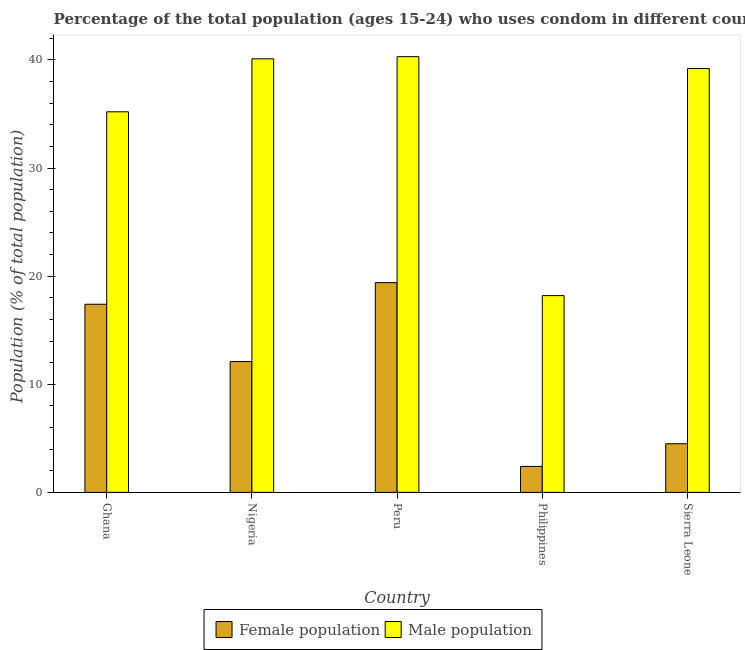How many different coloured bars are there?
Offer a terse response. 2. How many groups of bars are there?
Provide a short and direct response. 5. Are the number of bars on each tick of the X-axis equal?
Provide a short and direct response. Yes. How many bars are there on the 4th tick from the right?
Give a very brief answer. 2. What is the label of the 5th group of bars from the left?
Your answer should be very brief. Sierra Leone. In how many cases, is the number of bars for a given country not equal to the number of legend labels?
Offer a terse response. 0. What is the male population in Peru?
Give a very brief answer. 40.3. Across all countries, what is the maximum female population?
Offer a very short reply. 19.4. Across all countries, what is the minimum female population?
Ensure brevity in your answer.  2.4. In which country was the female population maximum?
Give a very brief answer. Peru. In which country was the female population minimum?
Ensure brevity in your answer.  Philippines. What is the total male population in the graph?
Keep it short and to the point. 173. What is the difference between the female population in Peru and that in Sierra Leone?
Make the answer very short. 14.9. What is the difference between the female population in Peru and the male population in Nigeria?
Make the answer very short. -20.7. What is the average male population per country?
Provide a succinct answer. 34.6. What is the difference between the male population and female population in Nigeria?
Your answer should be compact. 28. In how many countries, is the female population greater than 20 %?
Keep it short and to the point. 0. What is the ratio of the female population in Ghana to that in Peru?
Offer a terse response. 0.9. What is the difference between the highest and the second highest female population?
Provide a short and direct response. 2. Is the sum of the female population in Ghana and Peru greater than the maximum male population across all countries?
Make the answer very short. No. What does the 1st bar from the left in Peru represents?
Ensure brevity in your answer.  Female population. What does the 1st bar from the right in Ghana represents?
Make the answer very short. Male population. Are the values on the major ticks of Y-axis written in scientific E-notation?
Your answer should be compact. No. Where does the legend appear in the graph?
Offer a very short reply. Bottom center. What is the title of the graph?
Ensure brevity in your answer.  Percentage of the total population (ages 15-24) who uses condom in different countries. Does "Taxes on profits and capital gains" appear as one of the legend labels in the graph?
Your answer should be compact. No. What is the label or title of the X-axis?
Offer a very short reply. Country. What is the label or title of the Y-axis?
Your answer should be compact. Population (% of total population) . What is the Population (% of total population)  in Female population in Ghana?
Keep it short and to the point. 17.4. What is the Population (% of total population)  in Male population in Ghana?
Give a very brief answer. 35.2. What is the Population (% of total population)  in Female population in Nigeria?
Your response must be concise. 12.1. What is the Population (% of total population)  in Male population in Nigeria?
Ensure brevity in your answer.  40.1. What is the Population (% of total population)  of Male population in Peru?
Ensure brevity in your answer.  40.3. What is the Population (% of total population)  in Female population in Philippines?
Make the answer very short. 2.4. What is the Population (% of total population)  in Male population in Sierra Leone?
Provide a short and direct response. 39.2. Across all countries, what is the maximum Population (% of total population)  in Male population?
Offer a terse response. 40.3. What is the total Population (% of total population)  of Female population in the graph?
Your answer should be compact. 55.8. What is the total Population (% of total population)  of Male population in the graph?
Your answer should be very brief. 173. What is the difference between the Population (% of total population)  in Female population in Ghana and that in Nigeria?
Ensure brevity in your answer.  5.3. What is the difference between the Population (% of total population)  of Female population in Ghana and that in Peru?
Provide a succinct answer. -2. What is the difference between the Population (% of total population)  of Female population in Ghana and that in Philippines?
Keep it short and to the point. 15. What is the difference between the Population (% of total population)  of Male population in Ghana and that in Philippines?
Keep it short and to the point. 17. What is the difference between the Population (% of total population)  of Female population in Ghana and that in Sierra Leone?
Provide a succinct answer. 12.9. What is the difference between the Population (% of total population)  of Male population in Ghana and that in Sierra Leone?
Your response must be concise. -4. What is the difference between the Population (% of total population)  in Female population in Nigeria and that in Peru?
Give a very brief answer. -7.3. What is the difference between the Population (% of total population)  of Male population in Nigeria and that in Peru?
Keep it short and to the point. -0.2. What is the difference between the Population (% of total population)  of Male population in Nigeria and that in Philippines?
Keep it short and to the point. 21.9. What is the difference between the Population (% of total population)  of Female population in Nigeria and that in Sierra Leone?
Your answer should be compact. 7.6. What is the difference between the Population (% of total population)  of Male population in Nigeria and that in Sierra Leone?
Keep it short and to the point. 0.9. What is the difference between the Population (% of total population)  in Male population in Peru and that in Philippines?
Give a very brief answer. 22.1. What is the difference between the Population (% of total population)  in Female population in Peru and that in Sierra Leone?
Your answer should be compact. 14.9. What is the difference between the Population (% of total population)  of Male population in Peru and that in Sierra Leone?
Ensure brevity in your answer.  1.1. What is the difference between the Population (% of total population)  in Female population in Philippines and that in Sierra Leone?
Offer a terse response. -2.1. What is the difference between the Population (% of total population)  in Male population in Philippines and that in Sierra Leone?
Offer a terse response. -21. What is the difference between the Population (% of total population)  of Female population in Ghana and the Population (% of total population)  of Male population in Nigeria?
Offer a terse response. -22.7. What is the difference between the Population (% of total population)  of Female population in Ghana and the Population (% of total population)  of Male population in Peru?
Give a very brief answer. -22.9. What is the difference between the Population (% of total population)  in Female population in Ghana and the Population (% of total population)  in Male population in Sierra Leone?
Make the answer very short. -21.8. What is the difference between the Population (% of total population)  in Female population in Nigeria and the Population (% of total population)  in Male population in Peru?
Your response must be concise. -28.2. What is the difference between the Population (% of total population)  in Female population in Nigeria and the Population (% of total population)  in Male population in Philippines?
Your response must be concise. -6.1. What is the difference between the Population (% of total population)  of Female population in Nigeria and the Population (% of total population)  of Male population in Sierra Leone?
Give a very brief answer. -27.1. What is the difference between the Population (% of total population)  of Female population in Peru and the Population (% of total population)  of Male population in Sierra Leone?
Provide a succinct answer. -19.8. What is the difference between the Population (% of total population)  of Female population in Philippines and the Population (% of total population)  of Male population in Sierra Leone?
Your answer should be compact. -36.8. What is the average Population (% of total population)  of Female population per country?
Make the answer very short. 11.16. What is the average Population (% of total population)  of Male population per country?
Keep it short and to the point. 34.6. What is the difference between the Population (% of total population)  of Female population and Population (% of total population)  of Male population in Ghana?
Ensure brevity in your answer.  -17.8. What is the difference between the Population (% of total population)  in Female population and Population (% of total population)  in Male population in Nigeria?
Your response must be concise. -28. What is the difference between the Population (% of total population)  of Female population and Population (% of total population)  of Male population in Peru?
Make the answer very short. -20.9. What is the difference between the Population (% of total population)  in Female population and Population (% of total population)  in Male population in Philippines?
Give a very brief answer. -15.8. What is the difference between the Population (% of total population)  in Female population and Population (% of total population)  in Male population in Sierra Leone?
Provide a succinct answer. -34.7. What is the ratio of the Population (% of total population)  of Female population in Ghana to that in Nigeria?
Provide a short and direct response. 1.44. What is the ratio of the Population (% of total population)  in Male population in Ghana to that in Nigeria?
Provide a short and direct response. 0.88. What is the ratio of the Population (% of total population)  in Female population in Ghana to that in Peru?
Your answer should be compact. 0.9. What is the ratio of the Population (% of total population)  in Male population in Ghana to that in Peru?
Provide a succinct answer. 0.87. What is the ratio of the Population (% of total population)  of Female population in Ghana to that in Philippines?
Your answer should be compact. 7.25. What is the ratio of the Population (% of total population)  of Male population in Ghana to that in Philippines?
Keep it short and to the point. 1.93. What is the ratio of the Population (% of total population)  in Female population in Ghana to that in Sierra Leone?
Offer a very short reply. 3.87. What is the ratio of the Population (% of total population)  of Male population in Ghana to that in Sierra Leone?
Your answer should be very brief. 0.9. What is the ratio of the Population (% of total population)  of Female population in Nigeria to that in Peru?
Your answer should be compact. 0.62. What is the ratio of the Population (% of total population)  of Male population in Nigeria to that in Peru?
Your answer should be compact. 0.99. What is the ratio of the Population (% of total population)  in Female population in Nigeria to that in Philippines?
Give a very brief answer. 5.04. What is the ratio of the Population (% of total population)  of Male population in Nigeria to that in Philippines?
Your answer should be very brief. 2.2. What is the ratio of the Population (% of total population)  in Female population in Nigeria to that in Sierra Leone?
Give a very brief answer. 2.69. What is the ratio of the Population (% of total population)  of Male population in Nigeria to that in Sierra Leone?
Provide a succinct answer. 1.02. What is the ratio of the Population (% of total population)  in Female population in Peru to that in Philippines?
Offer a very short reply. 8.08. What is the ratio of the Population (% of total population)  of Male population in Peru to that in Philippines?
Your response must be concise. 2.21. What is the ratio of the Population (% of total population)  in Female population in Peru to that in Sierra Leone?
Your answer should be compact. 4.31. What is the ratio of the Population (% of total population)  in Male population in Peru to that in Sierra Leone?
Provide a short and direct response. 1.03. What is the ratio of the Population (% of total population)  in Female population in Philippines to that in Sierra Leone?
Provide a short and direct response. 0.53. What is the ratio of the Population (% of total population)  of Male population in Philippines to that in Sierra Leone?
Make the answer very short. 0.46. What is the difference between the highest and the second highest Population (% of total population)  in Female population?
Ensure brevity in your answer.  2. What is the difference between the highest and the lowest Population (% of total population)  of Male population?
Provide a short and direct response. 22.1. 